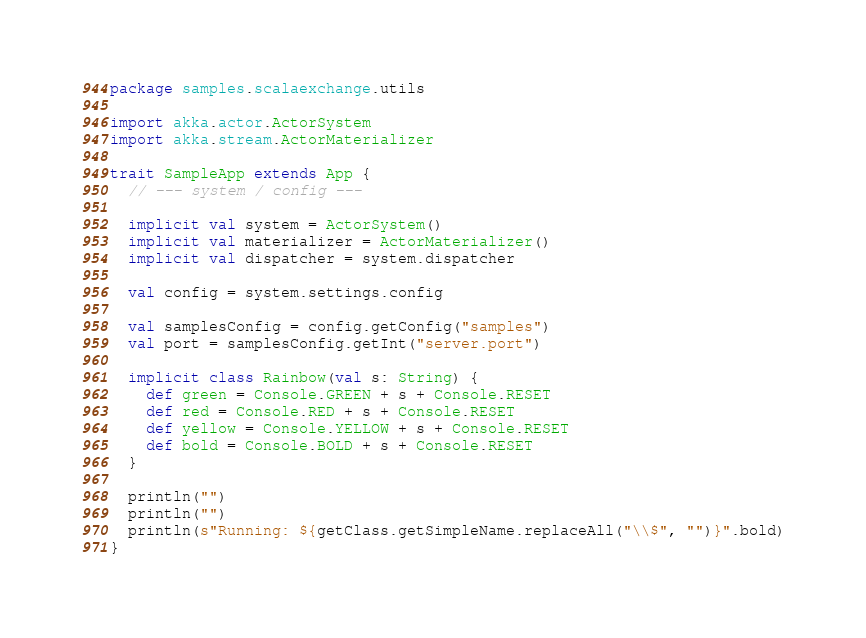Convert code to text. <code><loc_0><loc_0><loc_500><loc_500><_Scala_>package samples.scalaexchange.utils

import akka.actor.ActorSystem
import akka.stream.ActorMaterializer

trait SampleApp extends App {
  // --- system / config ---

  implicit val system = ActorSystem()
  implicit val materializer = ActorMaterializer()
  implicit val dispatcher = system.dispatcher

  val config = system.settings.config

  val samplesConfig = config.getConfig("samples")
  val port = samplesConfig.getInt("server.port")

  implicit class Rainbow(val s: String) {
    def green = Console.GREEN + s + Console.RESET
    def red = Console.RED + s + Console.RESET
    def yellow = Console.YELLOW + s + Console.RESET
    def bold = Console.BOLD + s + Console.RESET
  }

  println("")
  println("")
  println(s"Running: ${getClass.getSimpleName.replaceAll("\\$", "")}".bold)
}
</code> 